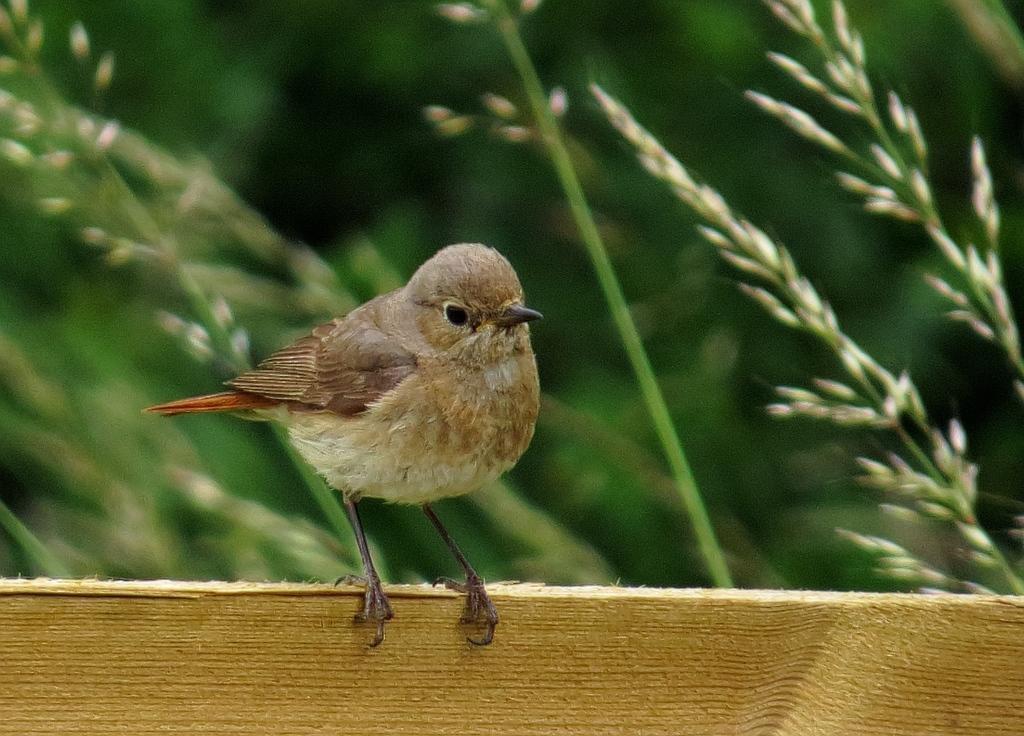In one or two sentences, can you explain what this image depicts? In this image we can see a bird on the wood and a blurry background. 